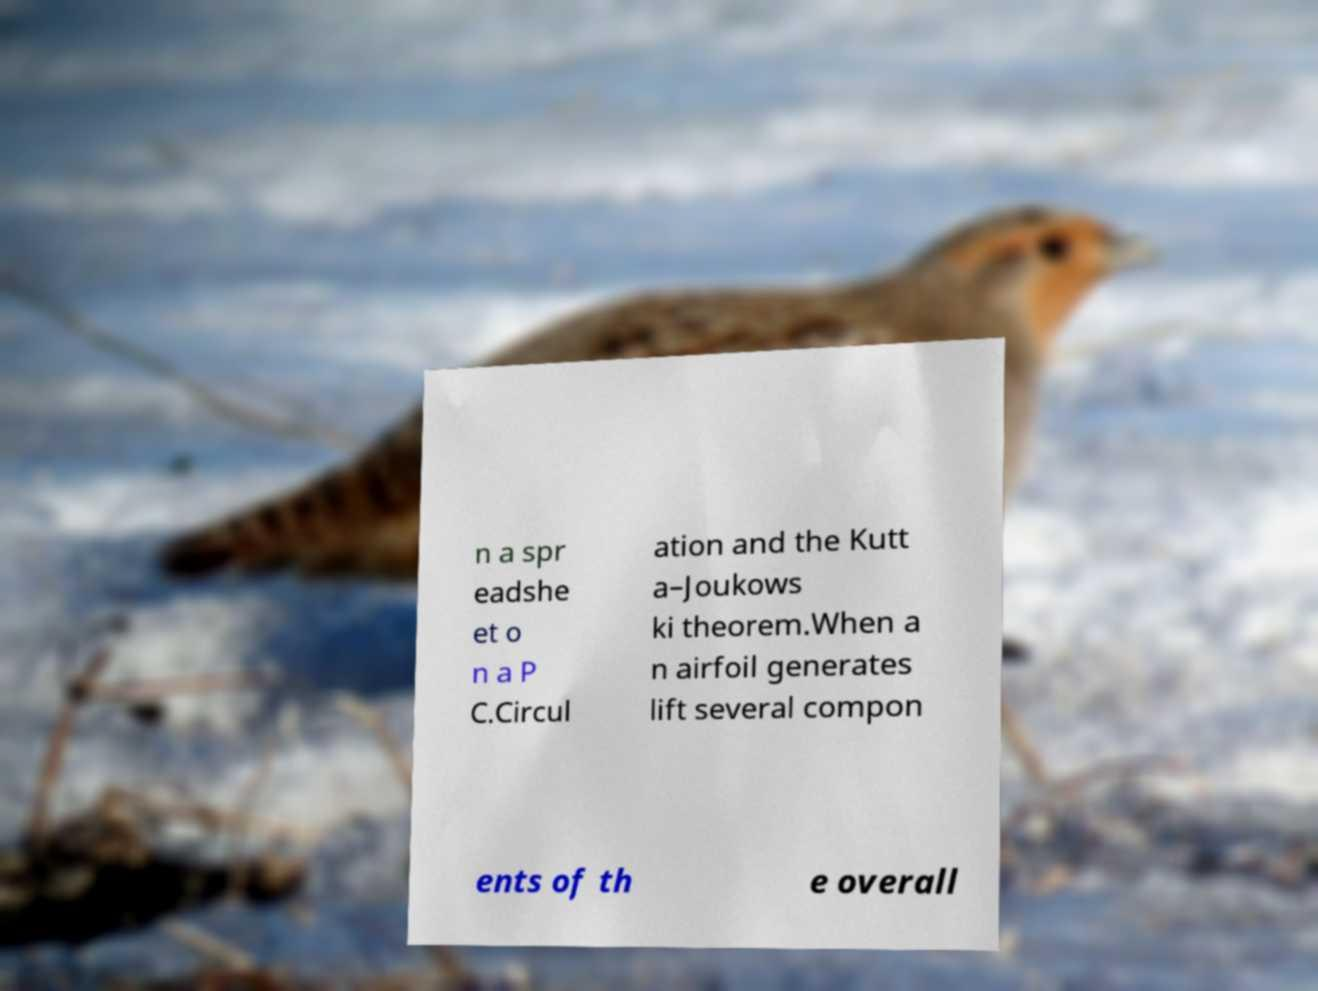There's text embedded in this image that I need extracted. Can you transcribe it verbatim? n a spr eadshe et o n a P C.Circul ation and the Kutt a–Joukows ki theorem.When a n airfoil generates lift several compon ents of th e overall 